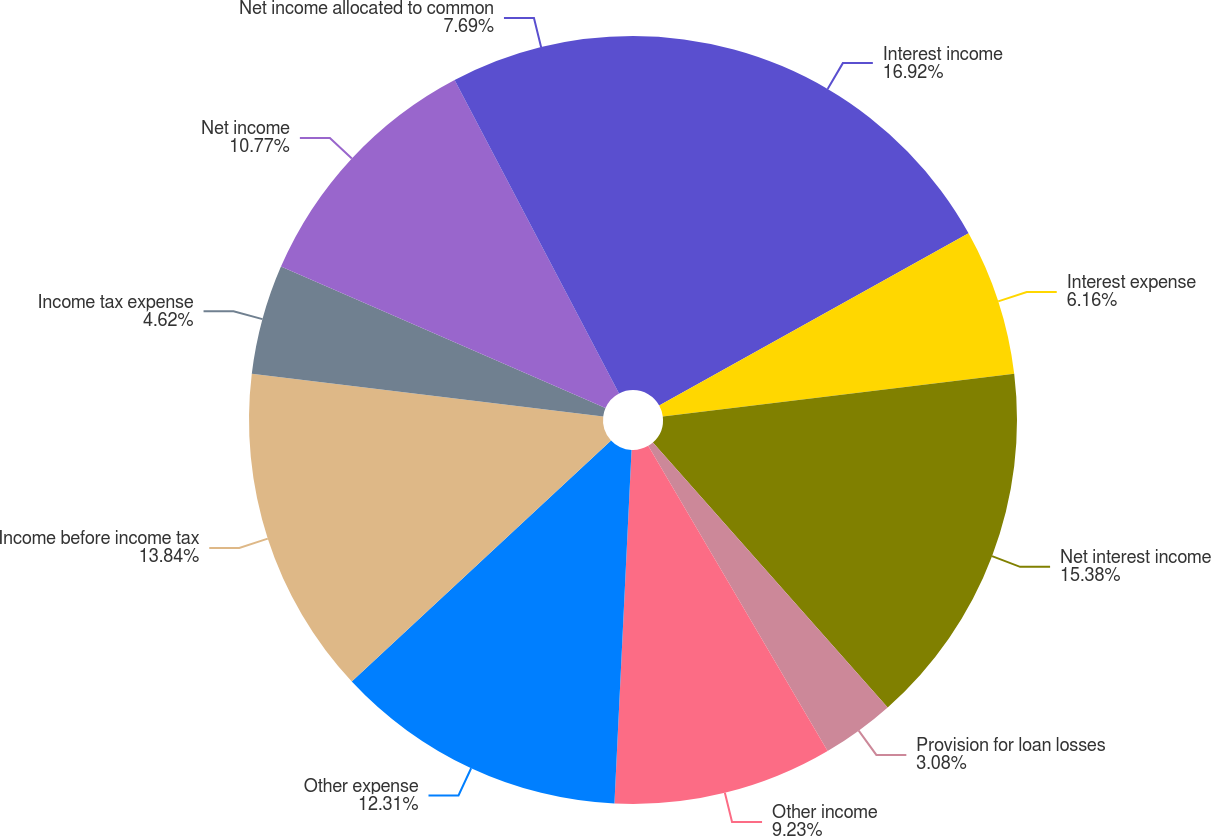Convert chart to OTSL. <chart><loc_0><loc_0><loc_500><loc_500><pie_chart><fcel>Interest income<fcel>Interest expense<fcel>Net interest income<fcel>Provision for loan losses<fcel>Other income<fcel>Other expense<fcel>Income before income tax<fcel>Income tax expense<fcel>Net income<fcel>Net income allocated to common<nl><fcel>16.92%<fcel>6.16%<fcel>15.38%<fcel>3.08%<fcel>9.23%<fcel>12.31%<fcel>13.84%<fcel>4.62%<fcel>10.77%<fcel>7.69%<nl></chart> 